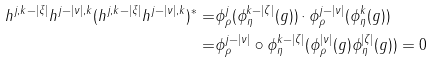<formula> <loc_0><loc_0><loc_500><loc_500>h ^ { j , k - | \xi | } h ^ { j - | \nu | , k } ( h ^ { j , k - | \xi | } h ^ { j - | \nu | , k } ) ^ { * } = & \phi _ { \rho } ^ { j } ( \phi _ { \eta } ^ { k - | \zeta | } ( g ) ) \cdot \phi _ { \rho } ^ { j - | \nu | } ( \phi _ { \eta } ^ { k } ( g ) ) \\ = & \phi _ { \rho } ^ { j - | \nu | } \circ \phi _ { \eta } ^ { k - | \zeta | } ( \phi _ { \rho } ^ { | \nu | } ( g ) \phi _ { \eta } ^ { | \zeta | } ( g ) ) = 0</formula> 